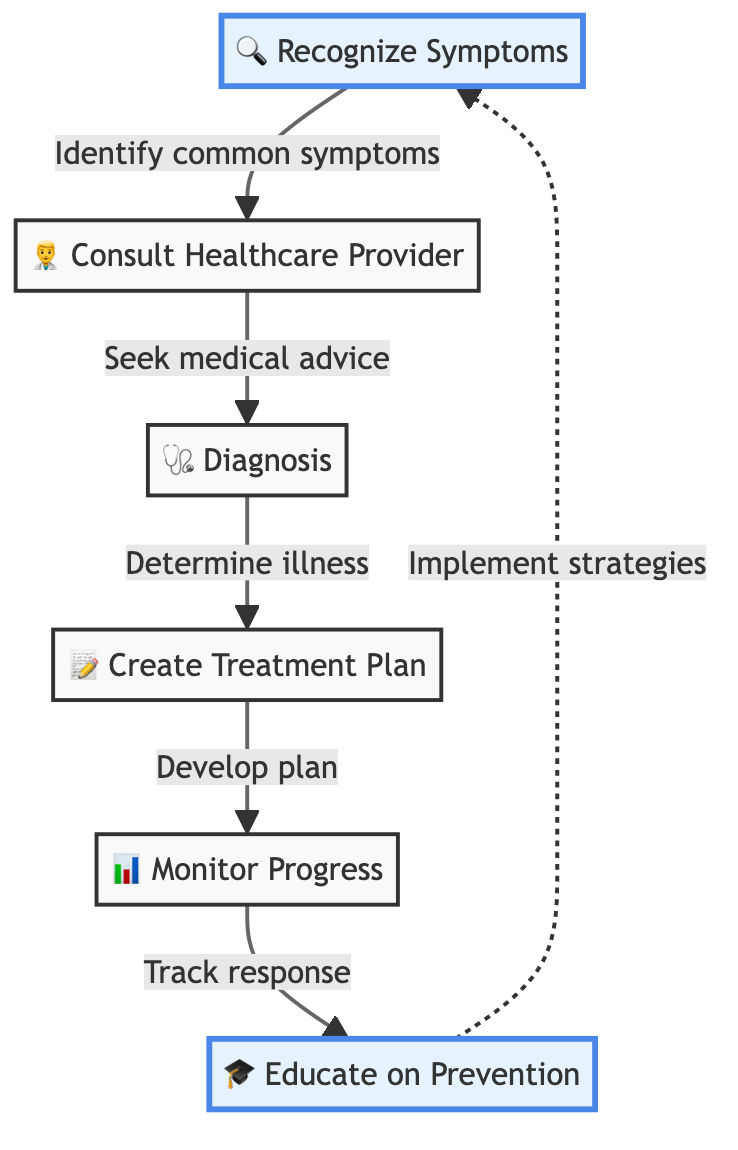What is the first step in the process? The diagram indicates that the first step is "Recognize Symptoms." This is identified from the top node in the flowchart.
Answer: Recognize Symptoms How many nodes are there in total? Counting all distinct points in the diagram, there are six nodes representing different steps in the process.
Answer: 6 What follows after consulting a healthcare provider? The flowchart shows that after "Consult Healthcare Provider," the next step is "Diagnosis." This is depicted by the direct arrow leading to the next node.
Answer: Diagnosis Which step discusses preventing illnesses? The last step in the diagram that addresses prevention is "Educate on Prevention." This step is highlighted in the flowchart indicating important strategies related to illness prevention.
Answer: Educate on Prevention What is the connection between monitoring progress and educating on prevention? The flowchart demonstrates a loop back from "Monitor Progress" to "Educate on Prevention." This indicates that monitoring the child’s health can influence and inform prevention strategies.
Answer: Track response What is the relationship between recognizing symptoms and consulting a healthcare provider? The diagram shows a direct arrow leading from "Recognize Symptoms" to "Consult Healthcare Provider," implying that recognizing symptoms prompts a parent's decision to seek professional advice.
Answer: Identify common symptoms 